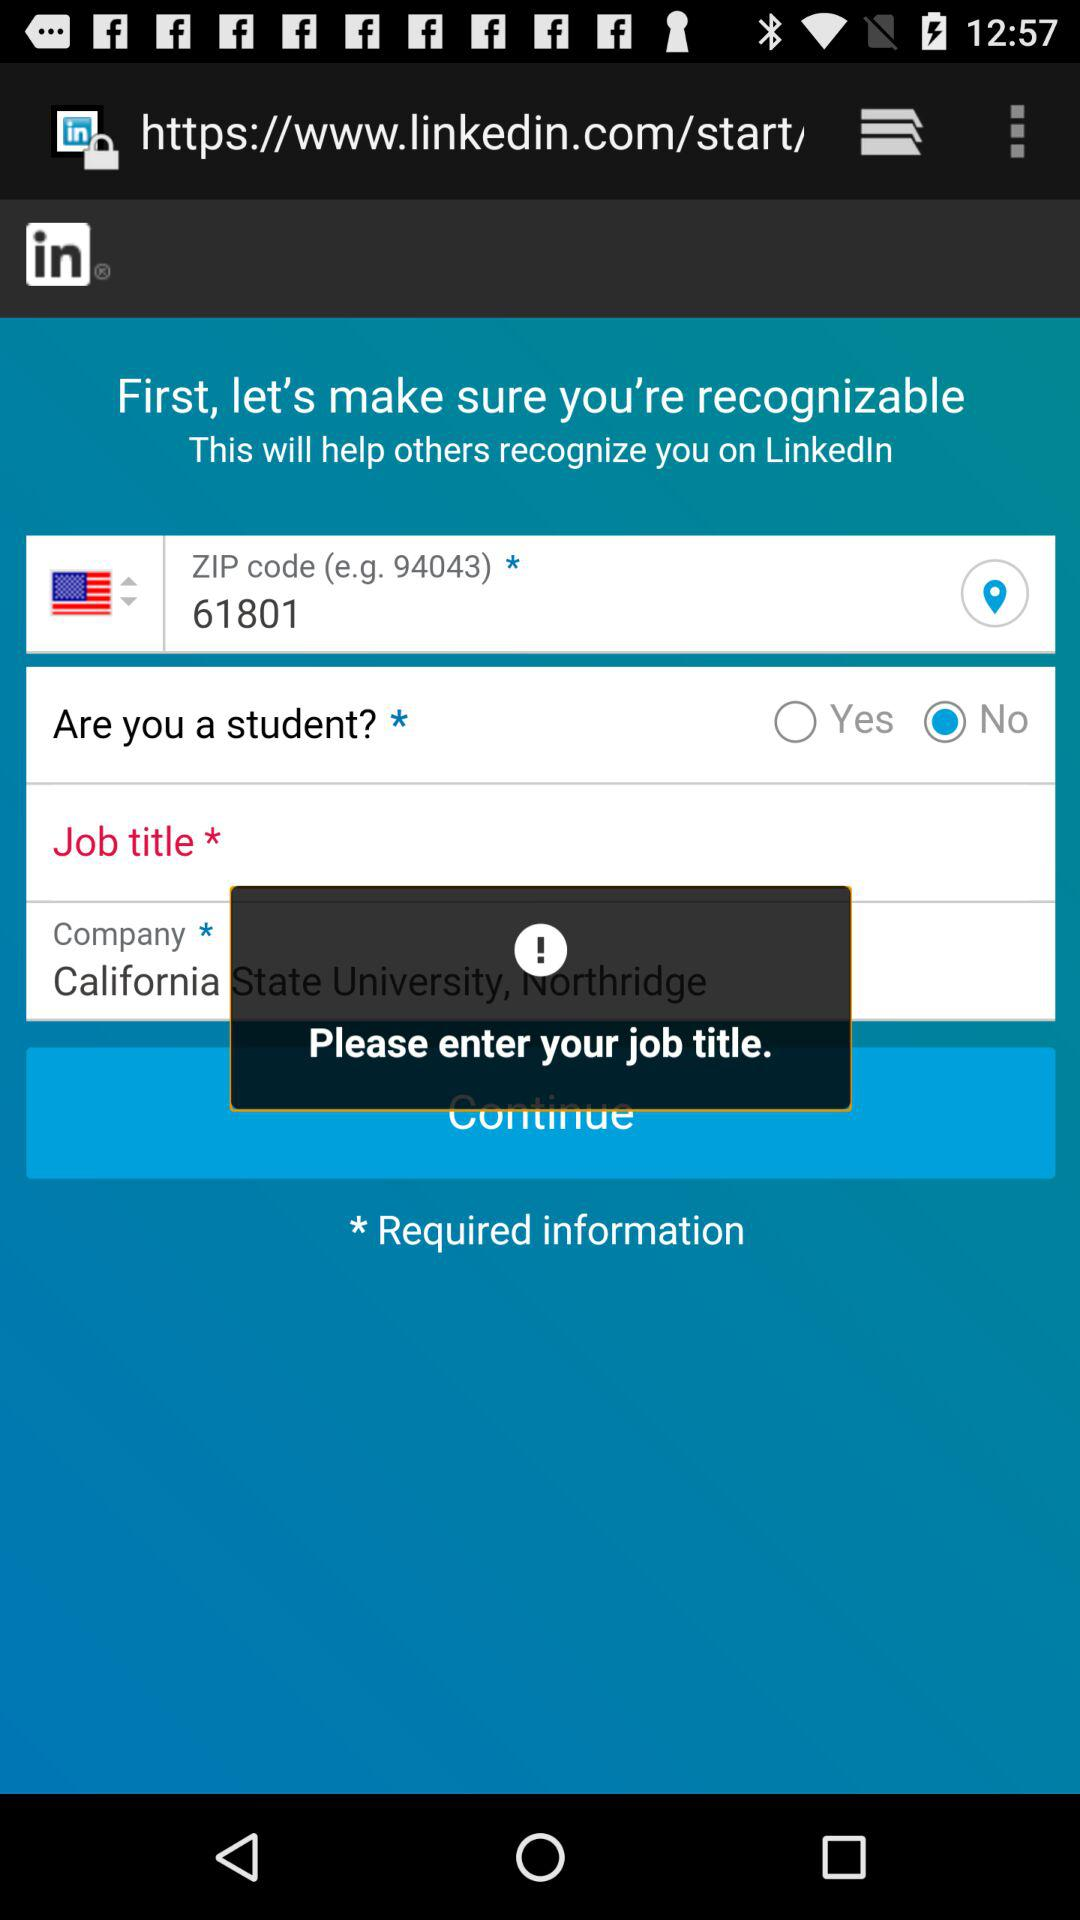What is the entered ZIP code? The entered ZIP code is 61801. 